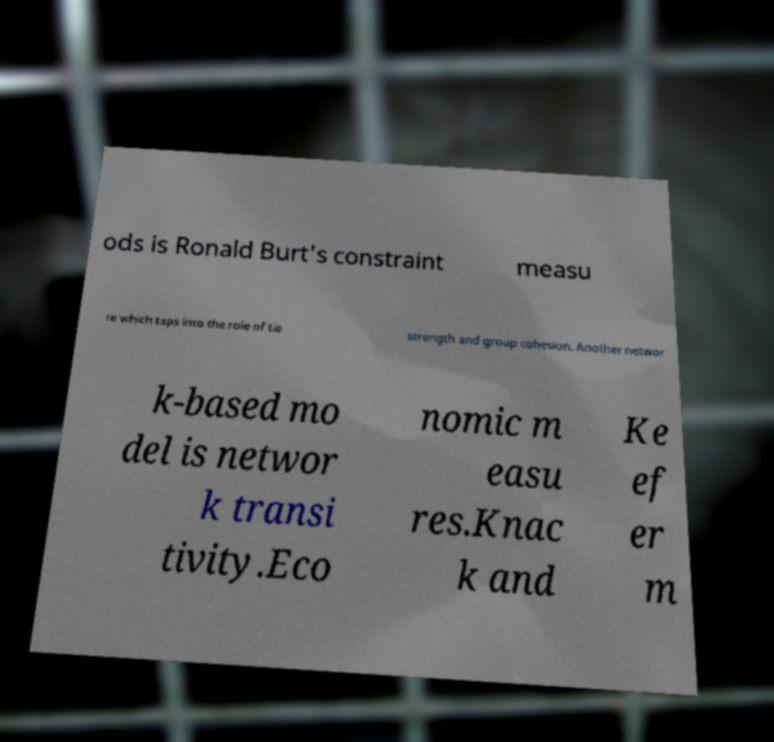What messages or text are displayed in this image? I need them in a readable, typed format. ods is Ronald Burt's constraint measu re which taps into the role of tie strength and group cohesion. Another networ k-based mo del is networ k transi tivity.Eco nomic m easu res.Knac k and Ke ef er m 